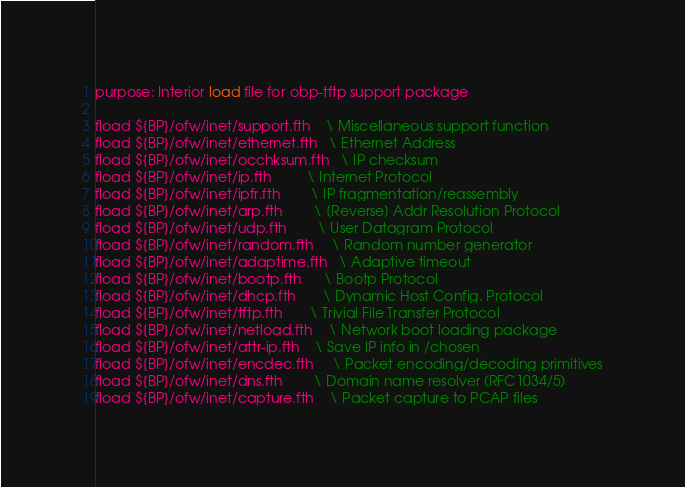<code> <loc_0><loc_0><loc_500><loc_500><_Forth_>purpose: Interior load file for obp-tftp support package

fload ${BP}/ofw/inet/support.fth    \ Miscellaneous support function
fload ${BP}/ofw/inet/ethernet.fth   \ Ethernet Address
fload ${BP}/ofw/inet/occhksum.fth   \ IP checksum
fload ${BP}/ofw/inet/ip.fth         \ Internet Protocol
fload ${BP}/ofw/inet/ipfr.fth	    \ IP fragmentation/reassembly
fload ${BP}/ofw/inet/arp.fth        \ [Reverse] Addr Resolution Protocol
fload ${BP}/ofw/inet/udp.fth        \ User Datagram Protocol
fload ${BP}/ofw/inet/random.fth     \ Random number generator
fload ${BP}/ofw/inet/adaptime.fth   \ Adaptive timeout
fload ${BP}/ofw/inet/bootp.fth      \ Bootp Protocol
fload ${BP}/ofw/inet/dhcp.fth       \ Dynamic Host Config. Protocol
fload ${BP}/ofw/inet/tftp.fth       \ Trivial File Transfer Protocol
fload ${BP}/ofw/inet/netload.fth    \ Network boot loading package
fload ${BP}/ofw/inet/attr-ip.fth    \ Save IP info in /chosen
fload ${BP}/ofw/inet/encdec.fth     \ Packet encoding/decoding primitives
fload ${BP}/ofw/inet/dns.fth	    \ Domain name resolver (RFC1034/5)
fload ${BP}/ofw/inet/capture.fth    \ Packet capture to PCAP files
</code> 